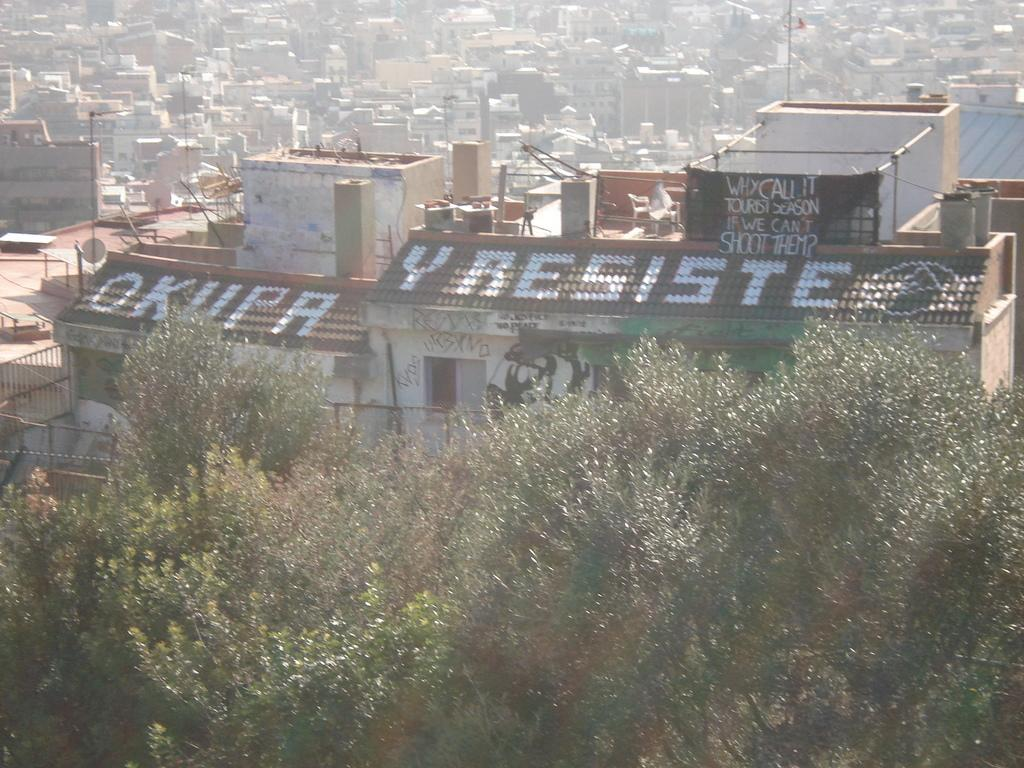What type of vegetation is present at the bottom of the image? There are trees with leaves at the bottom of the image. What structures can be seen in the background of the image? There are buildings in the background of the image. What else can be seen in the background of the image besides buildings? There are poles in the background of the image. What type of net is hanging from the trees in the image? There is no net present in the image; it only features trees with leaves, buildings, and poles. 